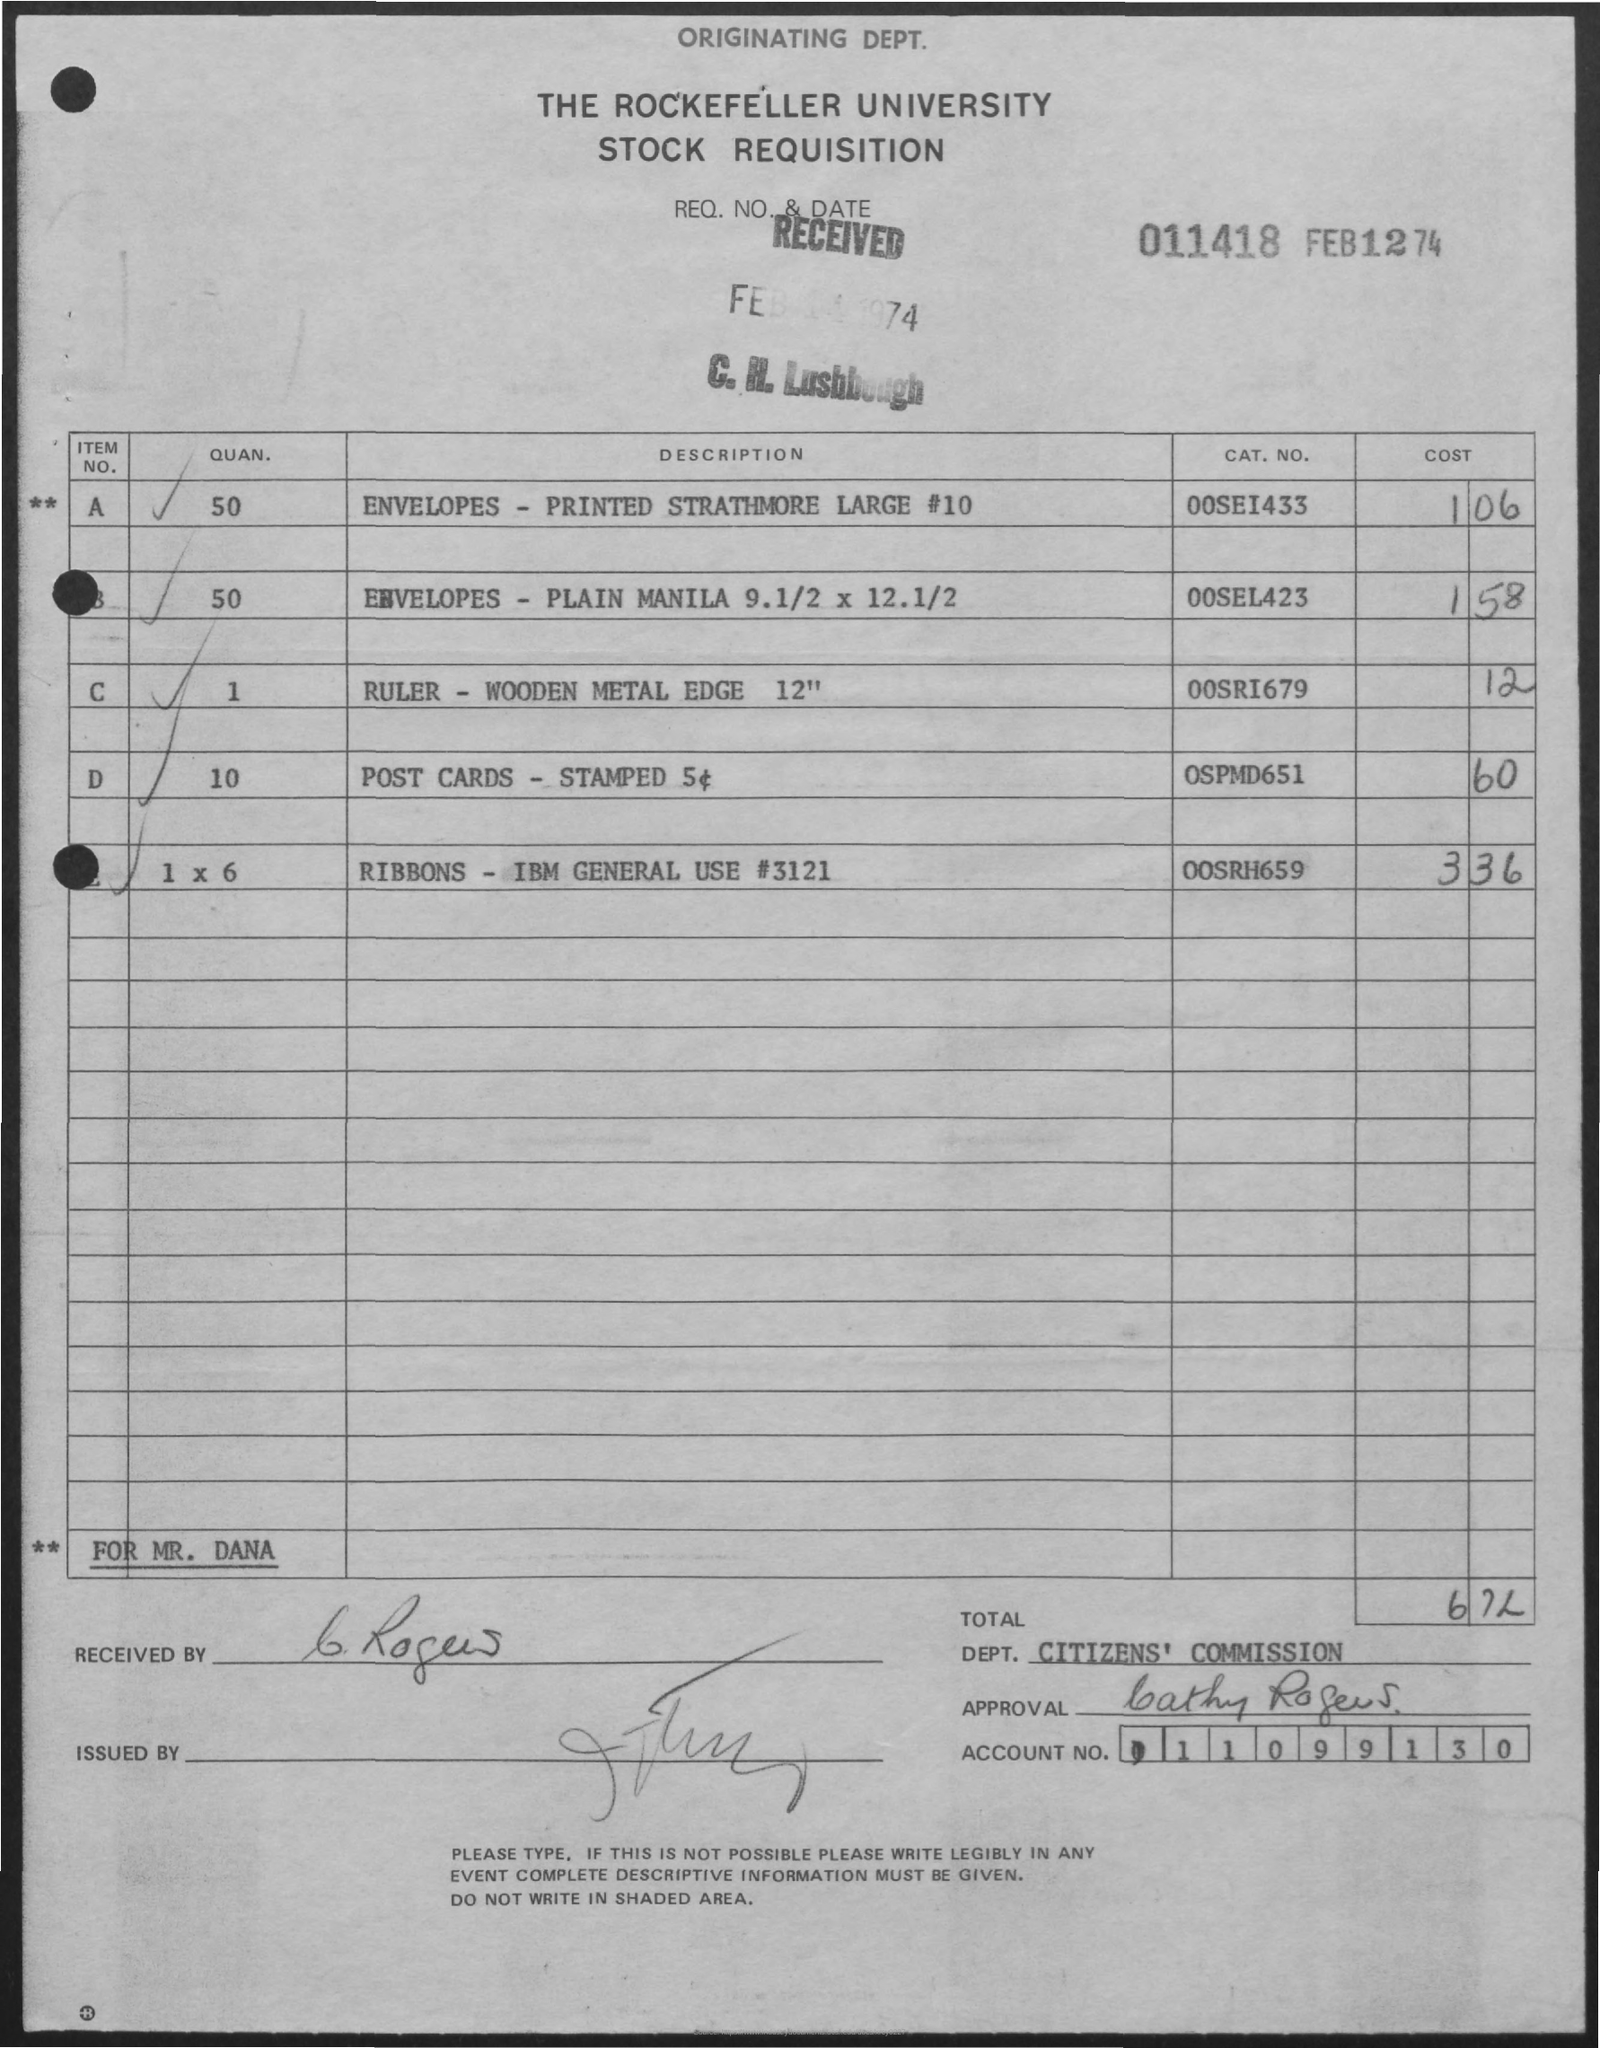Point out several critical features in this image. The cost of postcards stamped as mentioned on the given page is $0.60. The request number and date mentioned on the given page are 011418 and February 12, 74 respectively. The cost of the ruler mentioned on the given page is 12. What are the prices of the ribbons mentioned in the given page? The ribbons for general use from IBM have a catalog number of 3121, with a specific model number of 00SRH659. 